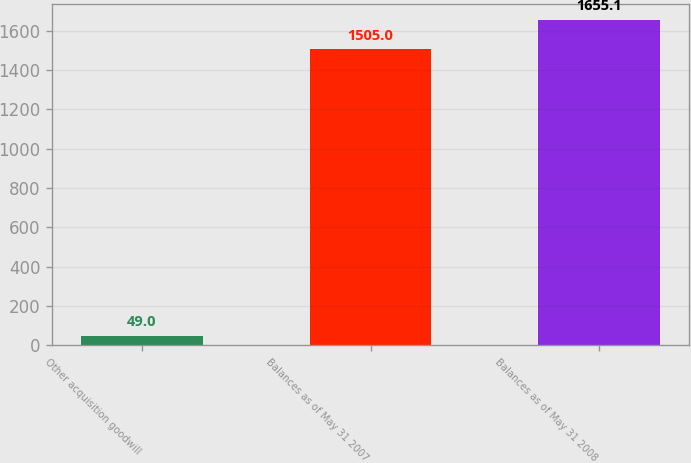Convert chart to OTSL. <chart><loc_0><loc_0><loc_500><loc_500><bar_chart><fcel>Other acquisition goodwill<fcel>Balances as of May 31 2007<fcel>Balances as of May 31 2008<nl><fcel>49<fcel>1505<fcel>1655.1<nl></chart> 